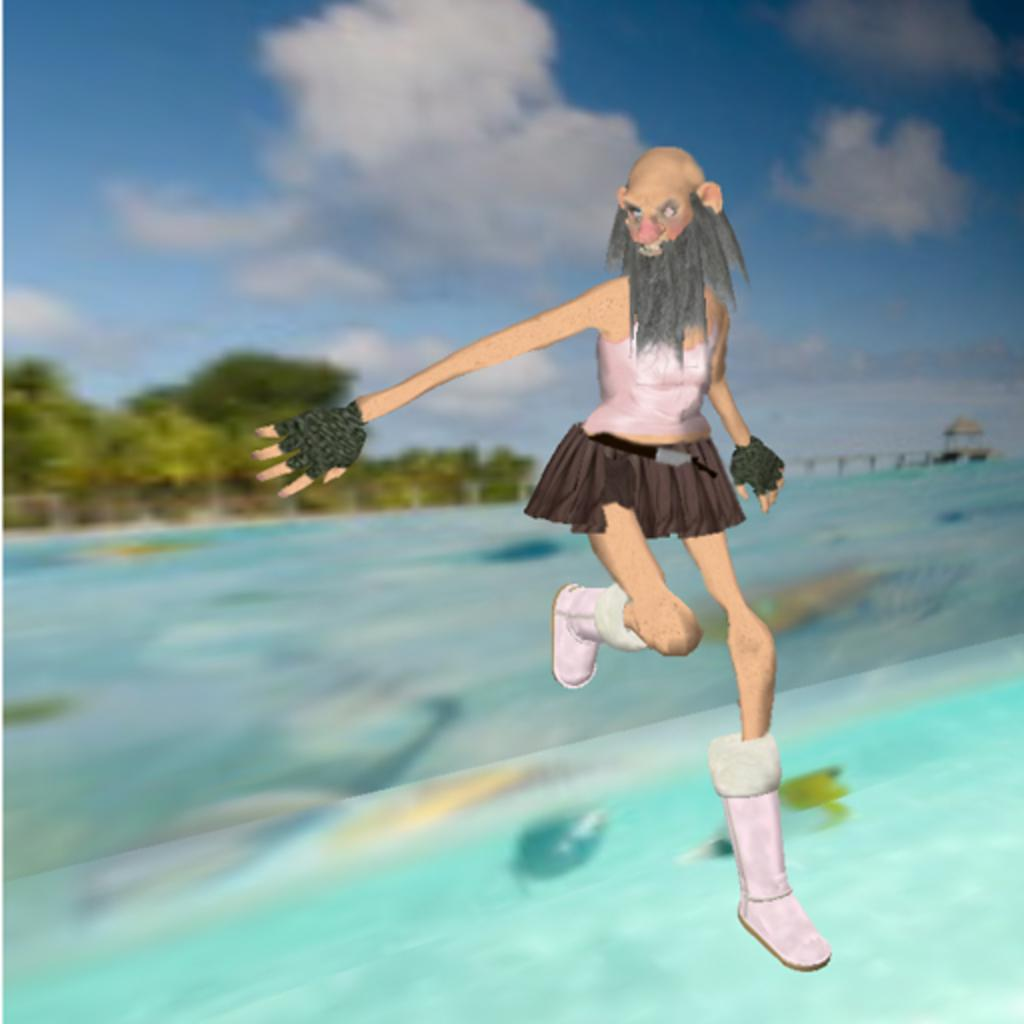What is depicted on the right side of the image? There is a painting of a person on the right side of the image. What can be seen in the background of the image? There is a fence and trees in the background of the image. What is visible in the sky in the image? Clouds are visible in the sky. What type of seed is being planted in the image? There is no seed or planting activity depicted in the image. How many pies are visible on the person's plate in the image? There is no plate or pies present in the image. 